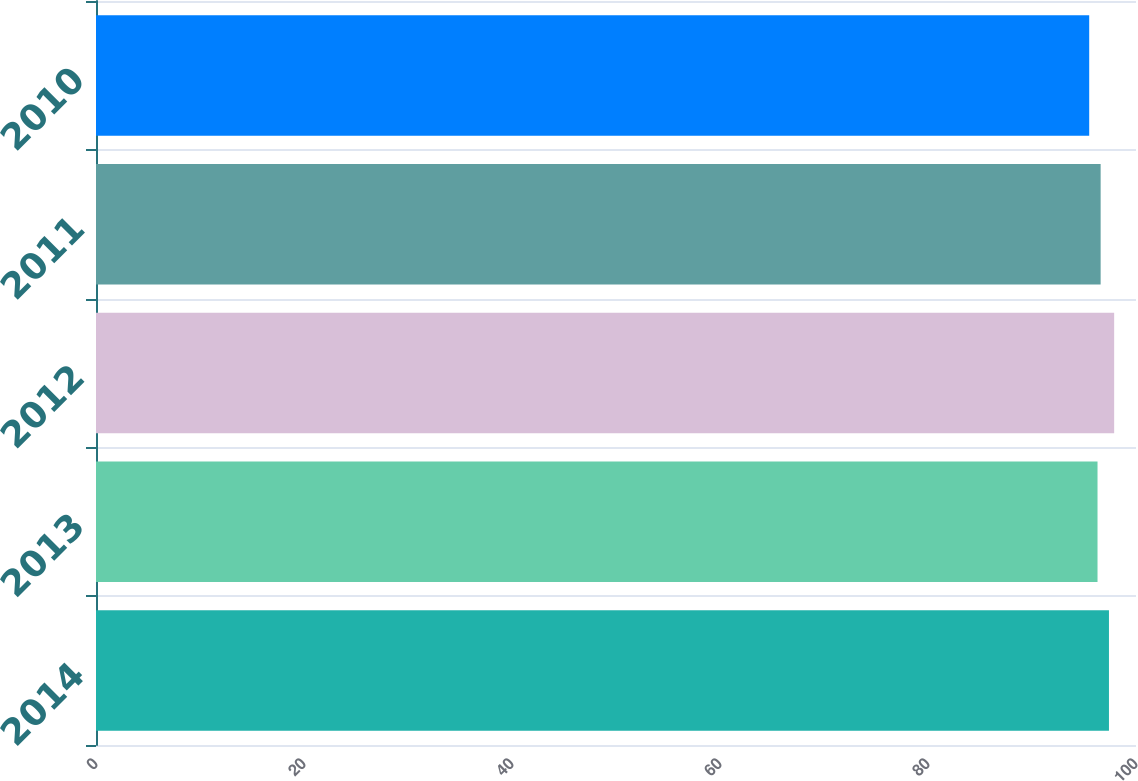Convert chart. <chart><loc_0><loc_0><loc_500><loc_500><bar_chart><fcel>2014<fcel>2013<fcel>2012<fcel>2011<fcel>2010<nl><fcel>97.4<fcel>96.3<fcel>97.9<fcel>96.6<fcel>95.5<nl></chart> 